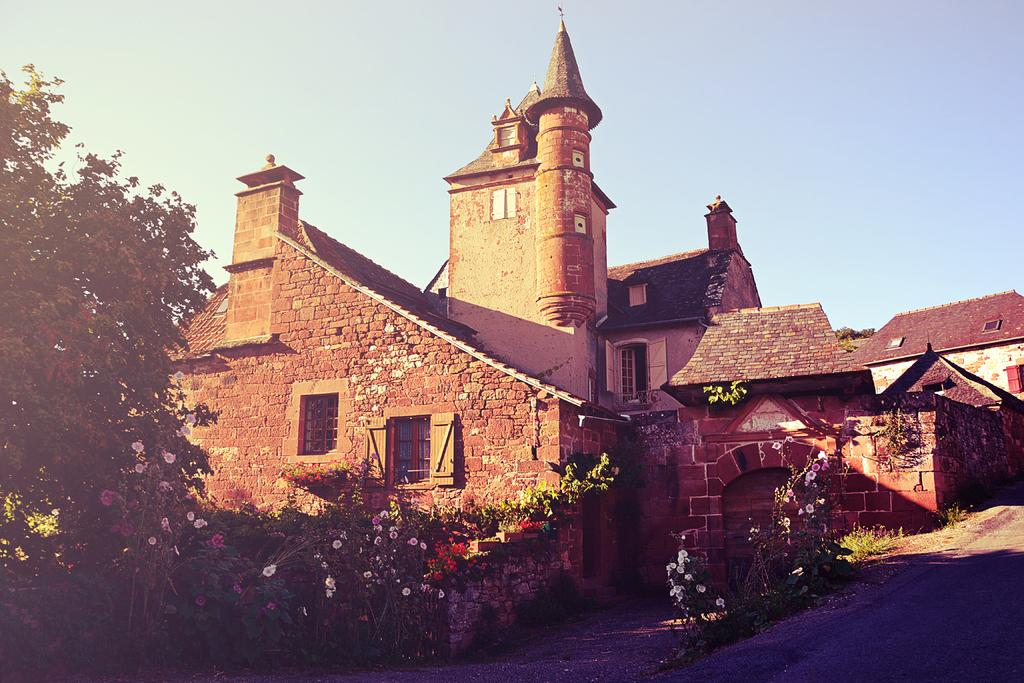What is the main subject in the center of the image? There is a house in the center of the image. What can be seen in the foreground of the image? There are plants and flowers in the foreground. What is located on the right side of the image? There is a walkway on the right side of the image. What is visible at the top of the image? The sky is visible at the top of the image. Where is the hospital located in the image? There is no hospital present in the image. What type of can is visible in the image? There is no can present in the image. 